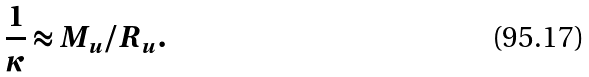Convert formula to latex. <formula><loc_0><loc_0><loc_500><loc_500>\frac { 1 } { \kappa } \approx M _ { u } / R _ { u } .</formula> 